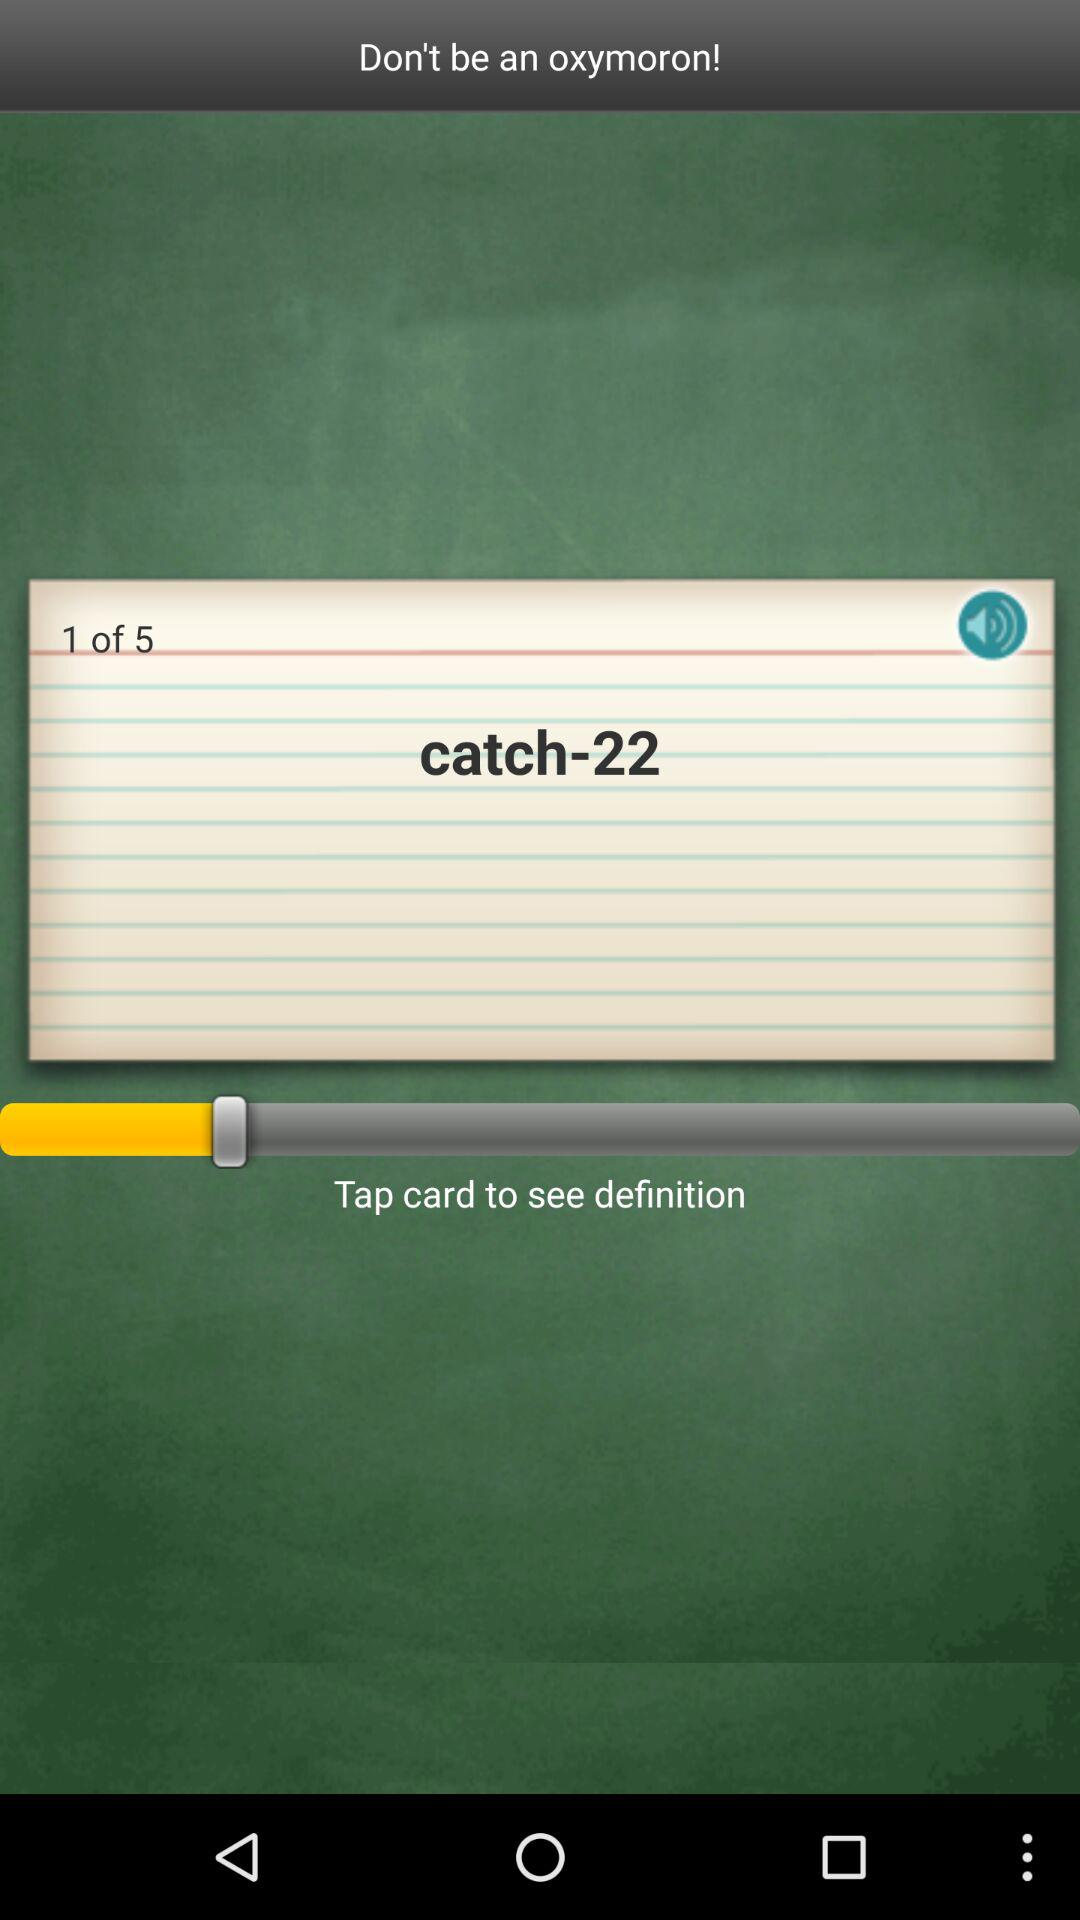How many pages in total are there? There are 5 pages in total. 